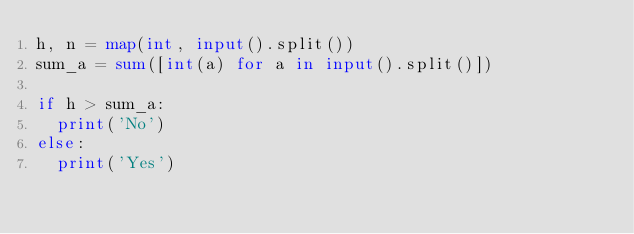<code> <loc_0><loc_0><loc_500><loc_500><_Python_>h, n = map(int, input().split())
sum_a = sum([int(a) for a in input().split()])

if h > sum_a:
  print('No')
else:
  print('Yes')
</code> 